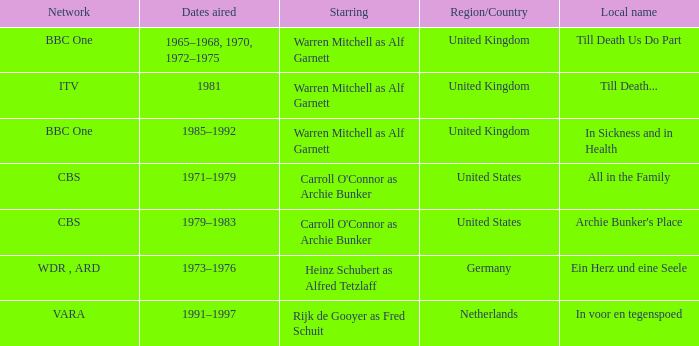What dates did the episodes air in the United States? 1971–1979, 1979–1983. 